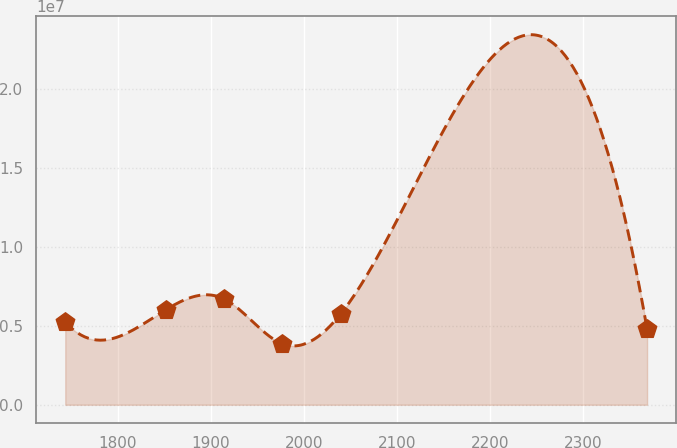<chart> <loc_0><loc_0><loc_500><loc_500><line_chart><ecel><fcel>Unnamed: 1<nl><fcel>1743.75<fcel>5.25453e+06<nl><fcel>1851.93<fcel>6.02403e+06<nl><fcel>1914.4<fcel>6.70108e+06<nl><fcel>1976.87<fcel>3.85757e+06<nl><fcel>2039.34<fcel>5.73968e+06<nl><fcel>2368.46<fcel>4.7945e+06<nl></chart> 